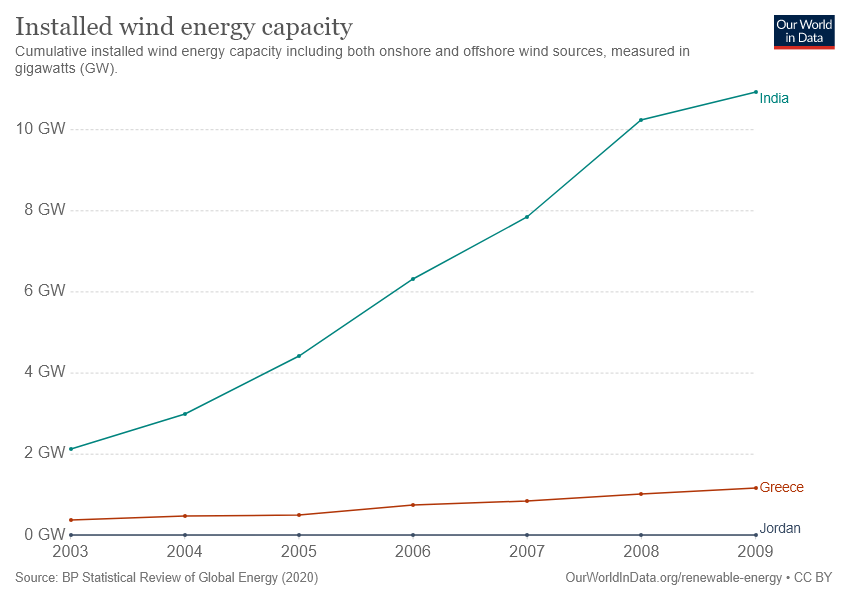Outline some significant characteristics in this image. India is the country where wind energy capacity started from 2 gigawatts and has since grown higher than 10 gigawatts. In 2009, Jordan showed the least amount of wind energy capacity among all places, with a significant reduction in the amount of Gigawatts generated. 